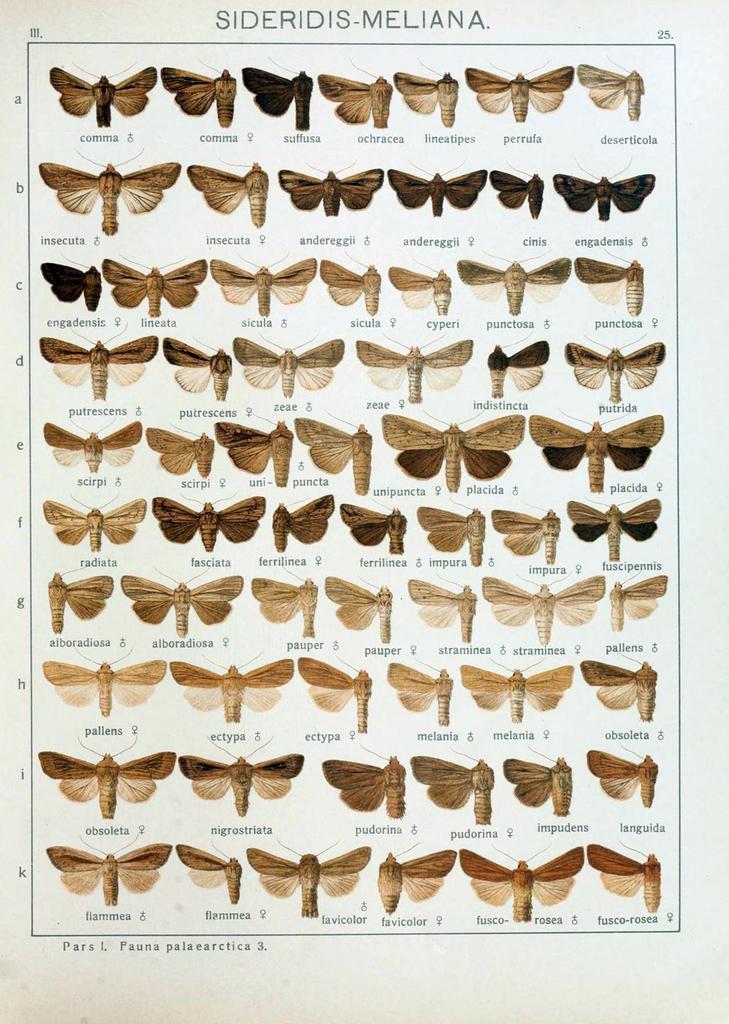How would you summarize this image in a sentence or two? This picture might be a painting on the paper. In this image, we can see butterflies on the paper. 